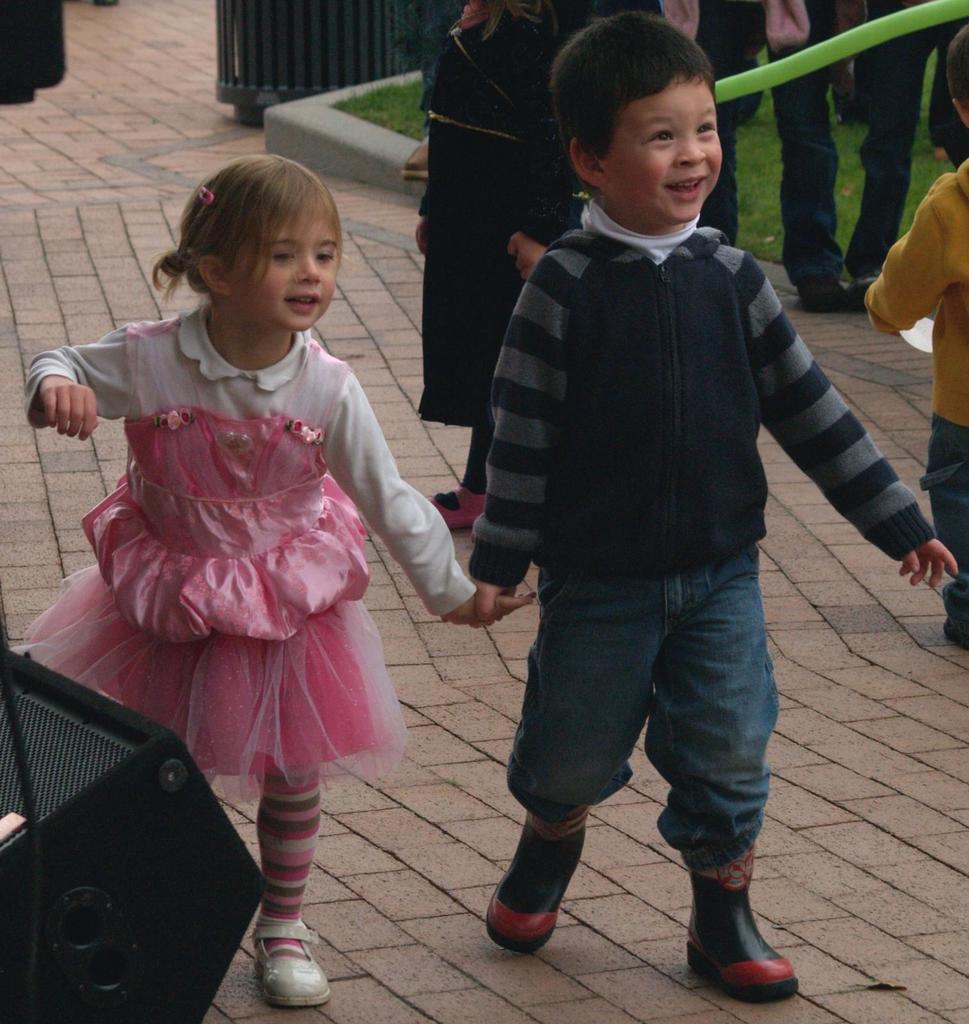How would you summarize this image in a sentence or two? In this picture there are two kids walking and smiling and there are group of people. At the back there is a dustbin. At the bottom left there is a speaker. At the bottom there is a pavement and there is grass. 